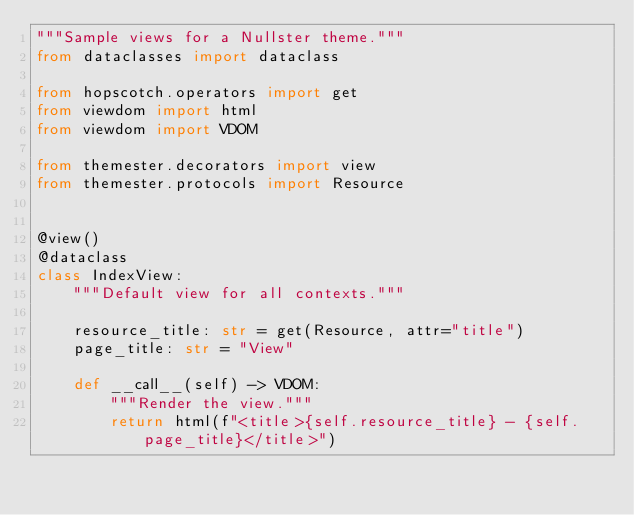Convert code to text. <code><loc_0><loc_0><loc_500><loc_500><_Python_>"""Sample views for a Nullster theme."""
from dataclasses import dataclass

from hopscotch.operators import get
from viewdom import html
from viewdom import VDOM

from themester.decorators import view
from themester.protocols import Resource


@view()
@dataclass
class IndexView:
    """Default view for all contexts."""

    resource_title: str = get(Resource, attr="title")
    page_title: str = "View"

    def __call__(self) -> VDOM:
        """Render the view."""
        return html(f"<title>{self.resource_title} - {self.page_title}</title>")
</code> 